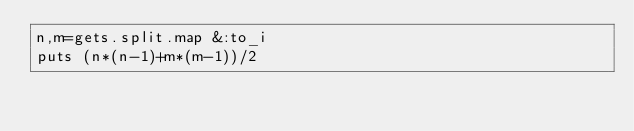<code> <loc_0><loc_0><loc_500><loc_500><_Ruby_>n,m=gets.split.map &:to_i
puts (n*(n-1)+m*(m-1))/2</code> 